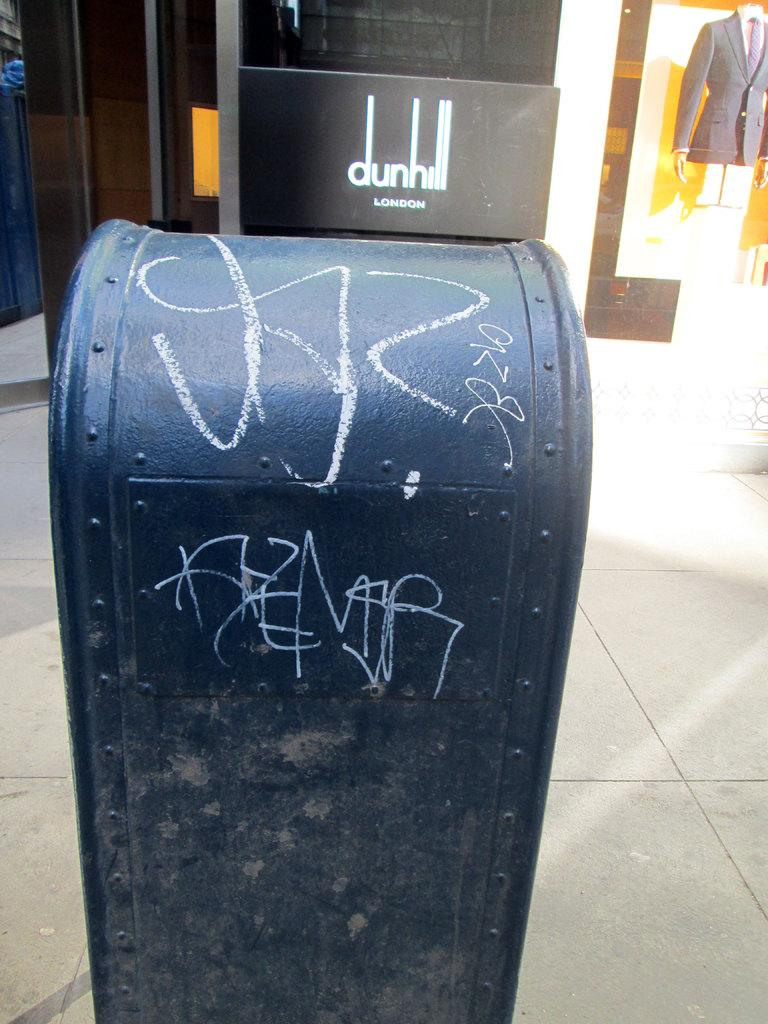<image>
Provide a brief description of the given image. The Dunhill London logo is next to some nasty graffiti. 